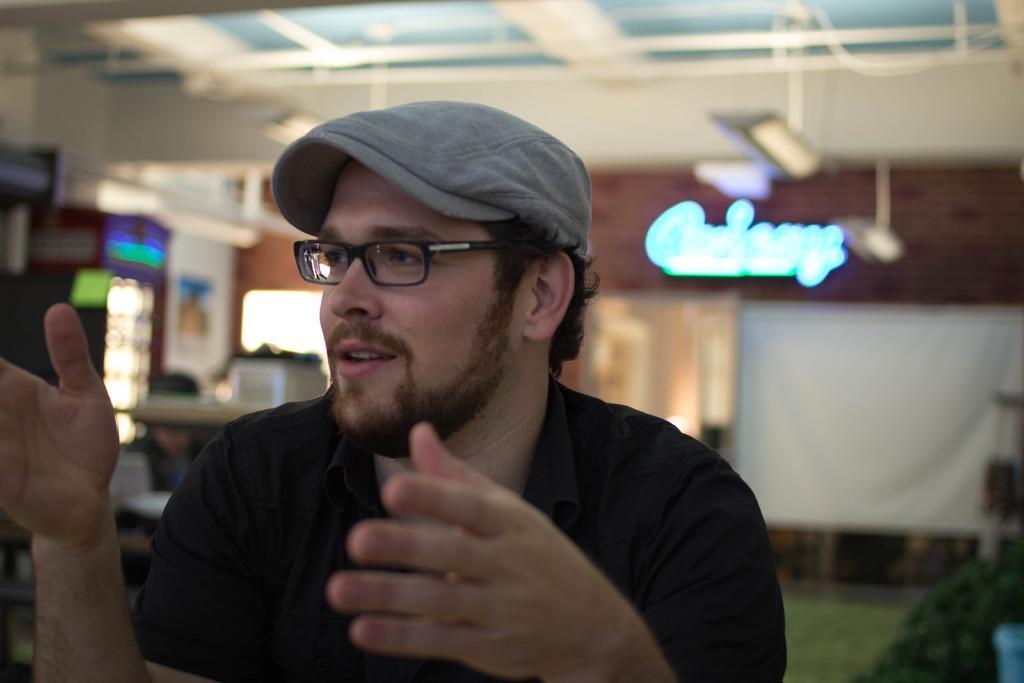How would you summarize this image in a sentence or two? In this picture we can observe a man wearing black color T shirt, spectacles and grey color cap on his head. In the background we can observe blue color light and white color cloth. The background is partially blurred. 